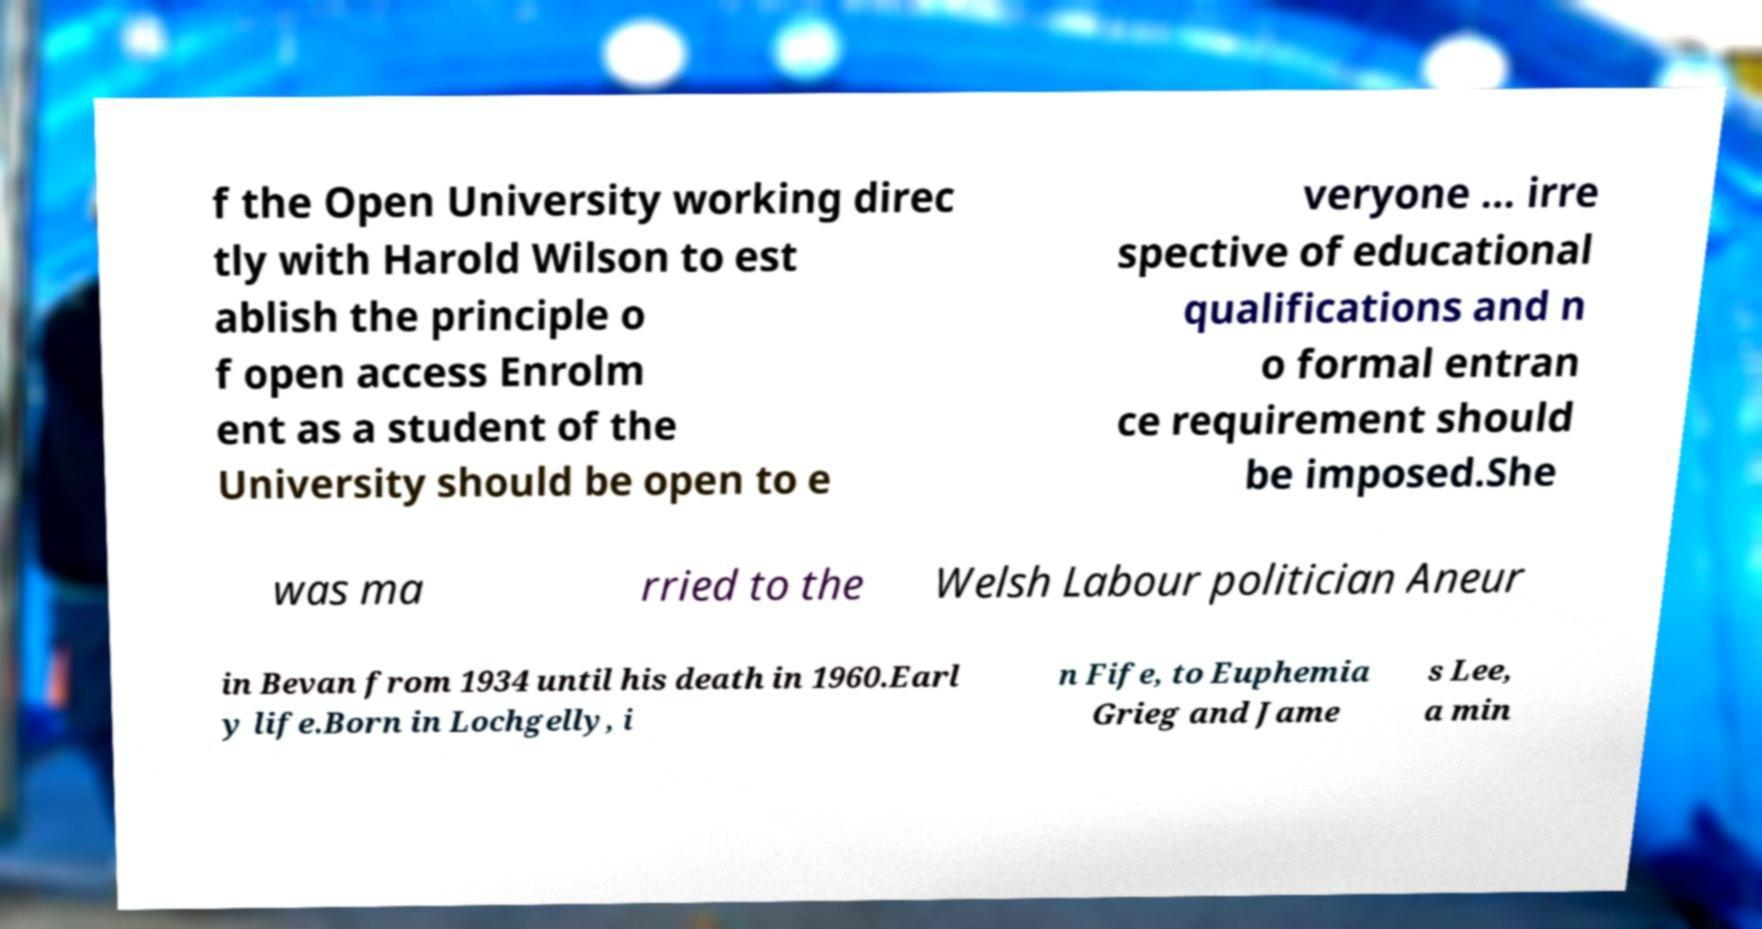Could you assist in decoding the text presented in this image and type it out clearly? f the Open University working direc tly with Harold Wilson to est ablish the principle o f open access Enrolm ent as a student of the University should be open to e veryone … irre spective of educational qualifications and n o formal entran ce requirement should be imposed.She was ma rried to the Welsh Labour politician Aneur in Bevan from 1934 until his death in 1960.Earl y life.Born in Lochgelly, i n Fife, to Euphemia Grieg and Jame s Lee, a min 